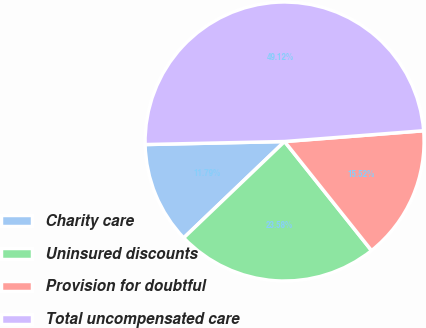Convert chart to OTSL. <chart><loc_0><loc_0><loc_500><loc_500><pie_chart><fcel>Charity care<fcel>Uninsured discounts<fcel>Provision for doubtful<fcel>Total uncompensated care<nl><fcel>11.79%<fcel>23.58%<fcel>15.52%<fcel>49.12%<nl></chart> 